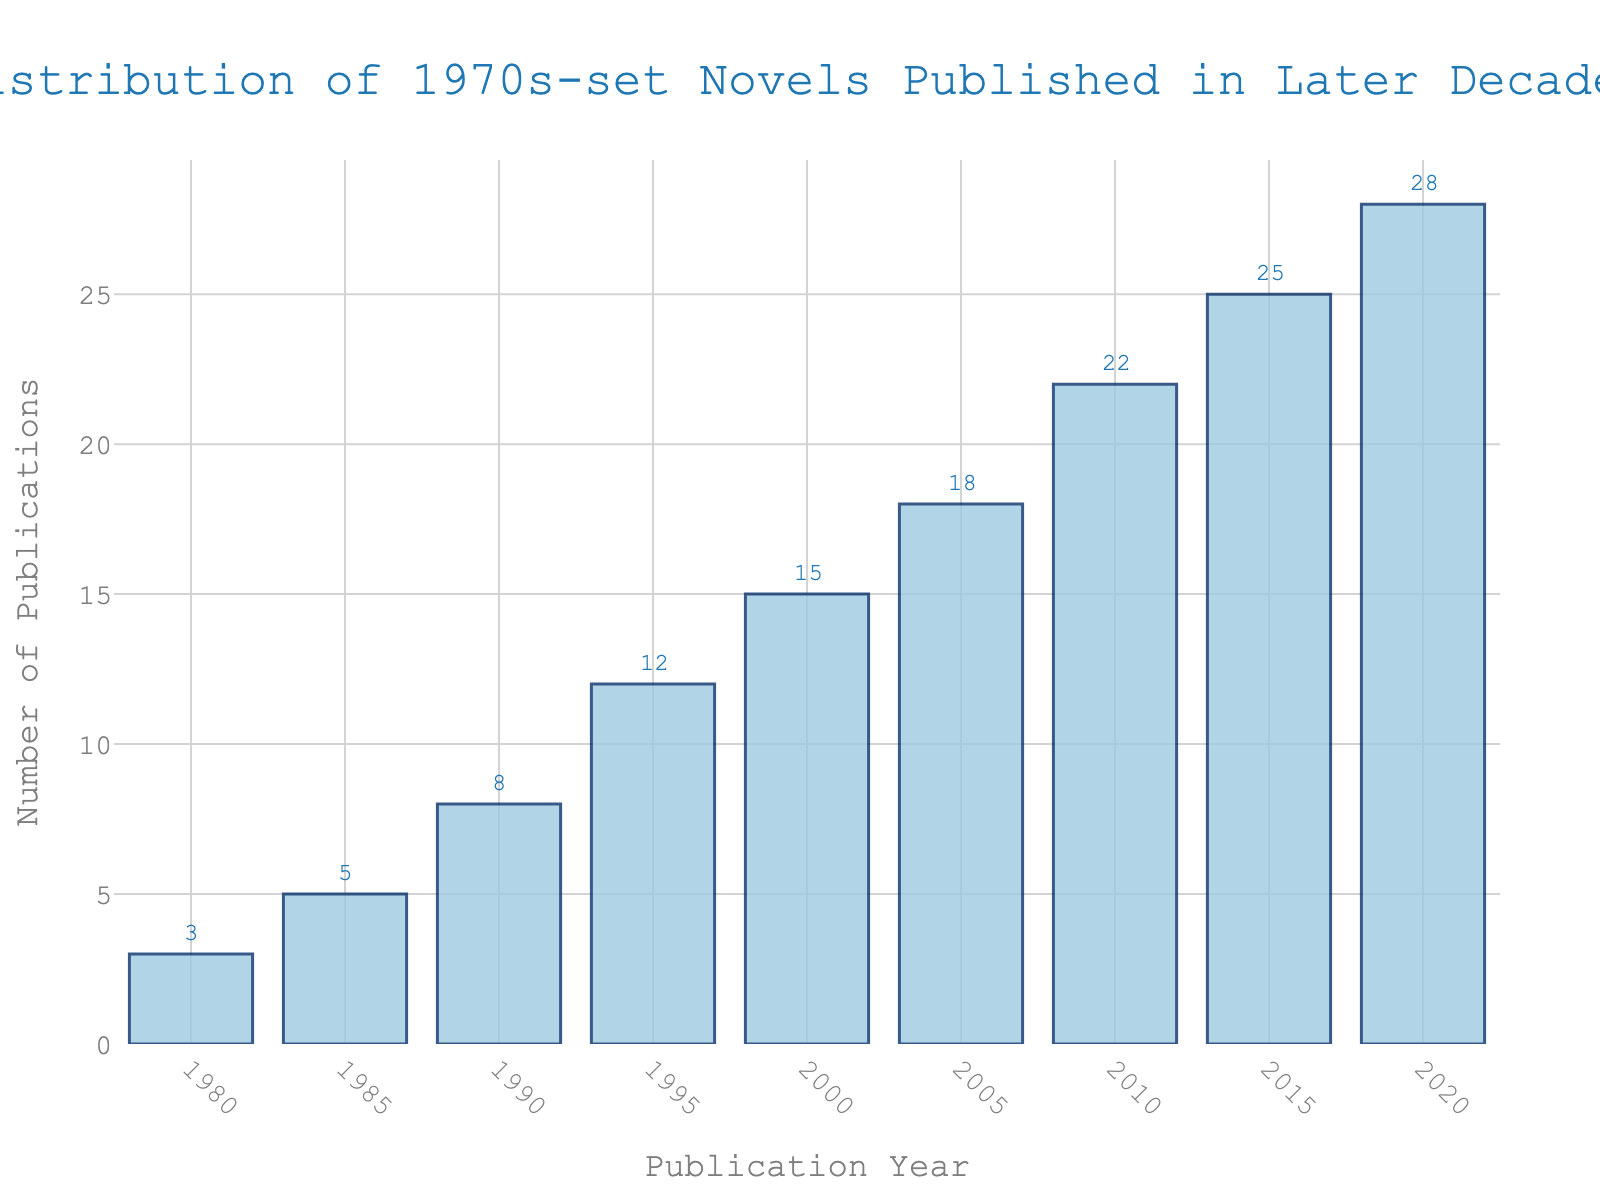What is the year with the highest number of publications? The bar chart shows that the year 2020 has the highest bar, representing the highest number of publications at 28.
Answer: 2020 How many more publications were there in 2020 compared to 2000? From the chart, we see that 2020 had 28 publications and 2000 had 15 publications. The difference is 28 - 15.
Answer: 13 What is the total number of publications from 1980 to 1990? Sum the number of publications from the years 1980, 1985, and 1990: 3 + 5 + 8.
Answer: 16 How has the number of publications changed from 1995 to 2015? The number of publications in 1995 was 12, and in 2015 it was 25. To find the change, subtract 12 from 25.
Answer: 13 Which year saw a doubling in the number of publications compared to 2005? The chart shows that 2005 had 18 publications. The year with double that would be 18 * 2 = 36. No exact year in the chart matches this exactly, but 2020 has 28 publications, which is close.
Answer: None exactly, but 2020 is the closest with 28 publications How many more publications were there in 2010 than in 1990? In 2010, there were 22 publications and in 1990, there were 8. The difference is 22 - 8.
Answer: 14 Calculate the average number of publications per decade, using the data provided. There are nine publication years from 1980 to 2020, and adding up all the publications: 3 + 5 + 8 + 12 + 15 + 18 + 22 + 25 + 28 = 136. Dividing by the number of years, 136 / 9.
Answer: 15.11 Between which consecutive years was the greatest increase in the number of publications observed? By observing the increases: 1980 to 1985 (2 more), 1985 to 1990 (3 more), 1990 to 1995 (4 more), 1995 to 2000 (3 more), 2000 to 2005 (3 more), 2005 to 2010 (4 more), 2010 to 2015 (3 more), 2015 to 2020 (3 more). The largest increase is from 2010 to 2020.
Answer: 2010 to 2015 What is the median number of publications for the given years? Ordering the publication counts: 3, 5, 8, 12, 15, 18, 22, 25, 28, the fifth and sixth numbers are 15 and 18. The median is the average of these two: (15 + 18) / 2.
Answer: 16.5 